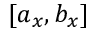<formula> <loc_0><loc_0><loc_500><loc_500>[ a _ { x } , b _ { x } ]</formula> 